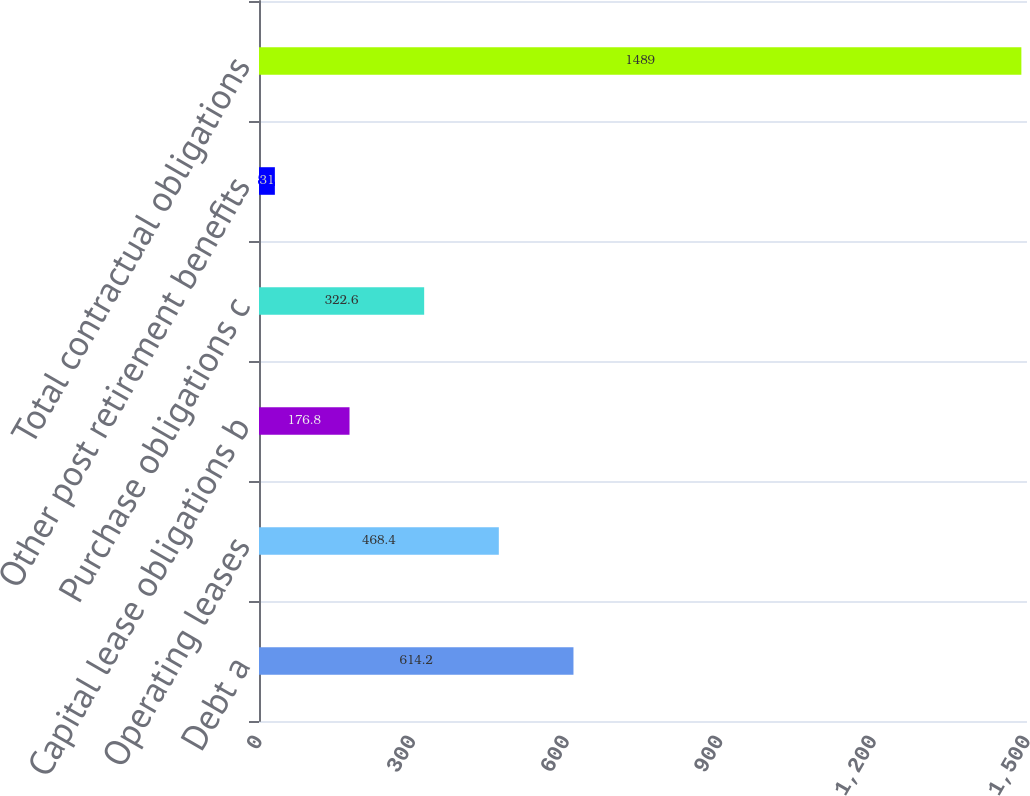Convert chart. <chart><loc_0><loc_0><loc_500><loc_500><bar_chart><fcel>Debt a<fcel>Operating leases<fcel>Capital lease obligations b<fcel>Purchase obligations c<fcel>Other post retirement benefits<fcel>Total contractual obligations<nl><fcel>614.2<fcel>468.4<fcel>176.8<fcel>322.6<fcel>31<fcel>1489<nl></chart> 